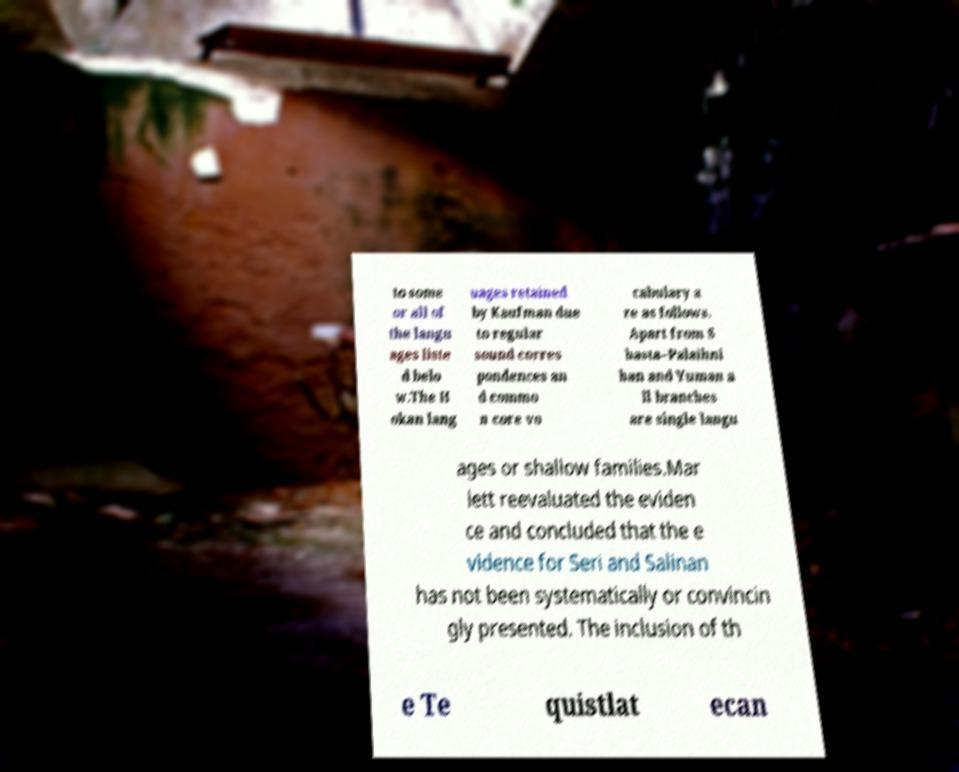Could you assist in decoding the text presented in this image and type it out clearly? to some or all of the langu ages liste d belo w.The H okan lang uages retained by Kaufman due to regular sound corres pondences an d commo n core vo cabulary a re as follows. Apart from S hasta–Palaihni han and Yuman a ll branches are single langu ages or shallow families.Mar lett reevaluated the eviden ce and concluded that the e vidence for Seri and Salinan has not been systematically or convincin gly presented. The inclusion of th e Te quistlat ecan 